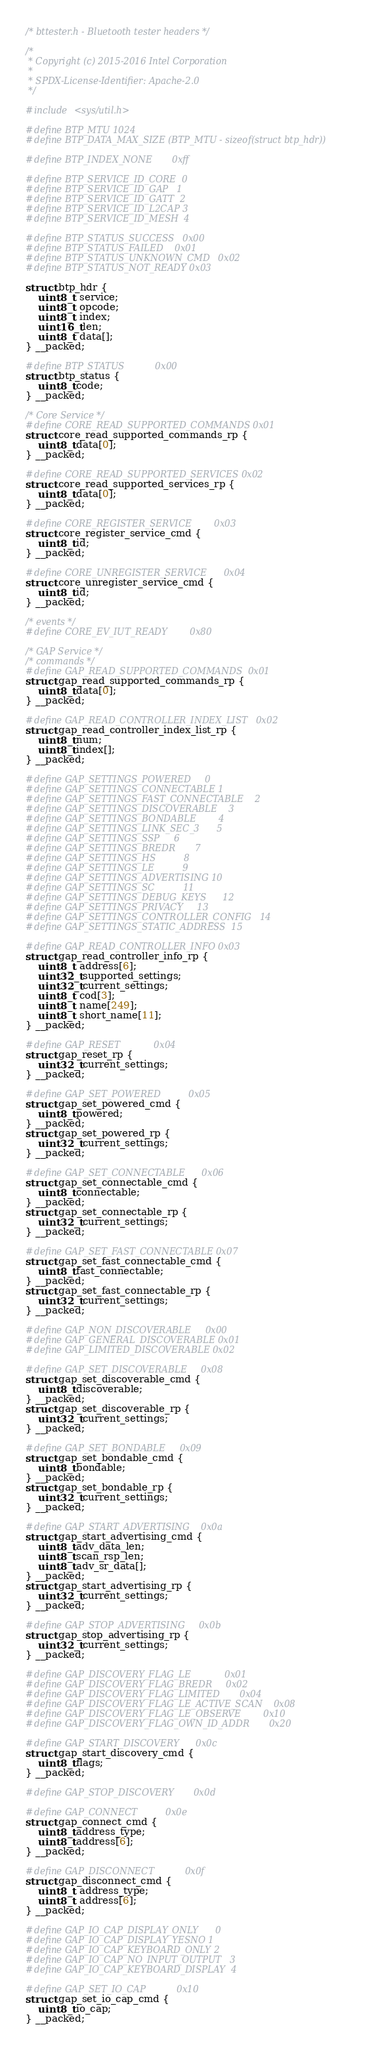Convert code to text. <code><loc_0><loc_0><loc_500><loc_500><_C_>/* bttester.h - Bluetooth tester headers */

/*
 * Copyright (c) 2015-2016 Intel Corporation
 *
 * SPDX-License-Identifier: Apache-2.0
 */

#include <sys/util.h>

#define BTP_MTU 1024
#define BTP_DATA_MAX_SIZE (BTP_MTU - sizeof(struct btp_hdr))

#define BTP_INDEX_NONE		0xff

#define BTP_SERVICE_ID_CORE	0
#define BTP_SERVICE_ID_GAP	1
#define BTP_SERVICE_ID_GATT	2
#define BTP_SERVICE_ID_L2CAP	3
#define BTP_SERVICE_ID_MESH	4

#define BTP_STATUS_SUCCESS	0x00
#define BTP_STATUS_FAILED	0x01
#define BTP_STATUS_UNKNOWN_CMD	0x02
#define BTP_STATUS_NOT_READY	0x03

struct btp_hdr {
	uint8_t  service;
	uint8_t  opcode;
	uint8_t  index;
	uint16_t len;
	uint8_t  data[];
} __packed;

#define BTP_STATUS			0x00
struct btp_status {
	uint8_t code;
} __packed;

/* Core Service */
#define CORE_READ_SUPPORTED_COMMANDS	0x01
struct core_read_supported_commands_rp {
	uint8_t data[0];
} __packed;

#define CORE_READ_SUPPORTED_SERVICES	0x02
struct core_read_supported_services_rp {
	uint8_t data[0];
} __packed;

#define CORE_REGISTER_SERVICE		0x03
struct core_register_service_cmd {
	uint8_t id;
} __packed;

#define CORE_UNREGISTER_SERVICE		0x04
struct core_unregister_service_cmd {
	uint8_t id;
} __packed;

/* events */
#define CORE_EV_IUT_READY		0x80

/* GAP Service */
/* commands */
#define GAP_READ_SUPPORTED_COMMANDS	0x01
struct gap_read_supported_commands_rp {
	uint8_t data[0];
} __packed;

#define GAP_READ_CONTROLLER_INDEX_LIST	0x02
struct gap_read_controller_index_list_rp {
	uint8_t num;
	uint8_t index[];
} __packed;

#define GAP_SETTINGS_POWERED		0
#define GAP_SETTINGS_CONNECTABLE	1
#define GAP_SETTINGS_FAST_CONNECTABLE	2
#define GAP_SETTINGS_DISCOVERABLE	3
#define GAP_SETTINGS_BONDABLE		4
#define GAP_SETTINGS_LINK_SEC_3		5
#define GAP_SETTINGS_SSP		6
#define GAP_SETTINGS_BREDR		7
#define GAP_SETTINGS_HS			8
#define GAP_SETTINGS_LE			9
#define GAP_SETTINGS_ADVERTISING	10
#define GAP_SETTINGS_SC			11
#define GAP_SETTINGS_DEBUG_KEYS		12
#define GAP_SETTINGS_PRIVACY		13
#define GAP_SETTINGS_CONTROLLER_CONFIG	14
#define GAP_SETTINGS_STATIC_ADDRESS	15

#define GAP_READ_CONTROLLER_INFO	0x03
struct gap_read_controller_info_rp {
	uint8_t  address[6];
	uint32_t supported_settings;
	uint32_t current_settings;
	uint8_t  cod[3];
	uint8_t  name[249];
	uint8_t  short_name[11];
} __packed;

#define GAP_RESET			0x04
struct gap_reset_rp {
	uint32_t current_settings;
} __packed;

#define GAP_SET_POWERED			0x05
struct gap_set_powered_cmd {
	uint8_t powered;
} __packed;
struct gap_set_powered_rp {
	uint32_t current_settings;
} __packed;

#define GAP_SET_CONNECTABLE		0x06
struct gap_set_connectable_cmd {
	uint8_t connectable;
} __packed;
struct gap_set_connectable_rp {
	uint32_t current_settings;
} __packed;

#define GAP_SET_FAST_CONNECTABLE	0x07
struct gap_set_fast_connectable_cmd {
	uint8_t fast_connectable;
} __packed;
struct gap_set_fast_connectable_rp {
	uint32_t current_settings;
} __packed;

#define GAP_NON_DISCOVERABLE		0x00
#define GAP_GENERAL_DISCOVERABLE	0x01
#define GAP_LIMITED_DISCOVERABLE	0x02

#define GAP_SET_DISCOVERABLE		0x08
struct gap_set_discoverable_cmd {
	uint8_t discoverable;
} __packed;
struct gap_set_discoverable_rp {
	uint32_t current_settings;
} __packed;

#define GAP_SET_BONDABLE		0x09
struct gap_set_bondable_cmd {
	uint8_t bondable;
} __packed;
struct gap_set_bondable_rp {
	uint32_t current_settings;
} __packed;

#define GAP_START_ADVERTISING	0x0a
struct gap_start_advertising_cmd {
	uint8_t adv_data_len;
	uint8_t scan_rsp_len;
	uint8_t adv_sr_data[];
} __packed;
struct gap_start_advertising_rp {
	uint32_t current_settings;
} __packed;

#define GAP_STOP_ADVERTISING		0x0b
struct gap_stop_advertising_rp {
	uint32_t current_settings;
} __packed;

#define GAP_DISCOVERY_FLAG_LE			0x01
#define GAP_DISCOVERY_FLAG_BREDR		0x02
#define GAP_DISCOVERY_FLAG_LIMITED		0x04
#define GAP_DISCOVERY_FLAG_LE_ACTIVE_SCAN	0x08
#define GAP_DISCOVERY_FLAG_LE_OBSERVE		0x10
#define GAP_DISCOVERY_FLAG_OWN_ID_ADDR		0x20

#define GAP_START_DISCOVERY		0x0c
struct gap_start_discovery_cmd {
	uint8_t flags;
} __packed;

#define GAP_STOP_DISCOVERY		0x0d

#define GAP_CONNECT			0x0e
struct gap_connect_cmd {
	uint8_t address_type;
	uint8_t address[6];
} __packed;

#define GAP_DISCONNECT			0x0f
struct gap_disconnect_cmd {
	uint8_t  address_type;
	uint8_t  address[6];
} __packed;

#define GAP_IO_CAP_DISPLAY_ONLY		0
#define GAP_IO_CAP_DISPLAY_YESNO	1
#define GAP_IO_CAP_KEYBOARD_ONLY	2
#define GAP_IO_CAP_NO_INPUT_OUTPUT	3
#define GAP_IO_CAP_KEYBOARD_DISPLAY	4

#define GAP_SET_IO_CAP			0x10
struct gap_set_io_cap_cmd {
	uint8_t io_cap;
} __packed;
</code> 